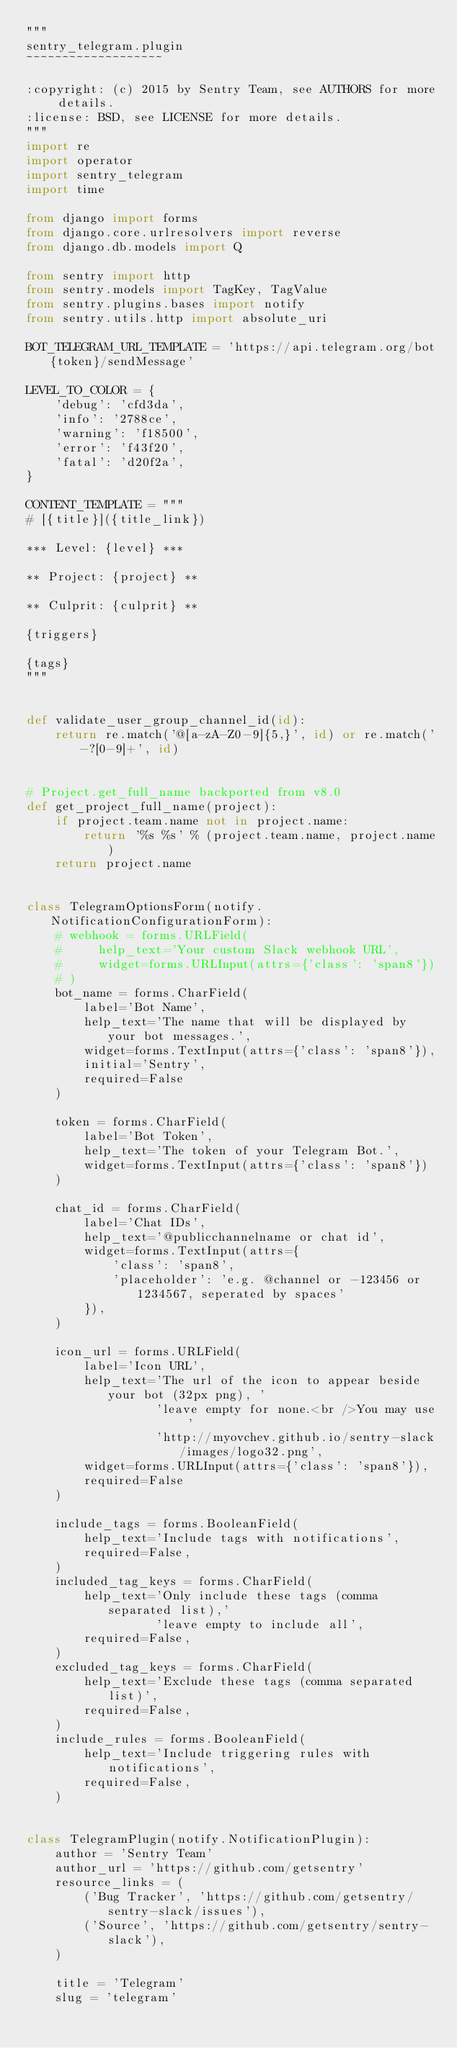<code> <loc_0><loc_0><loc_500><loc_500><_Python_>"""
sentry_telegram.plugin
~~~~~~~~~~~~~~~~~~~

:copyright: (c) 2015 by Sentry Team, see AUTHORS for more details.
:license: BSD, see LICENSE for more details.
"""
import re
import operator
import sentry_telegram
import time

from django import forms
from django.core.urlresolvers import reverse
from django.db.models import Q

from sentry import http
from sentry.models import TagKey, TagValue
from sentry.plugins.bases import notify
from sentry.utils.http import absolute_uri

BOT_TELEGRAM_URL_TEMPLATE = 'https://api.telegram.org/bot{token}/sendMessage'

LEVEL_TO_COLOR = {
    'debug': 'cfd3da',
    'info': '2788ce',
    'warning': 'f18500',
    'error': 'f43f20',
    'fatal': 'd20f2a',
}

CONTENT_TEMPLATE = """
# [{title}]({title_link})

*** Level: {level} ***

** Project: {project} **

** Culprit: {culprit} **

{triggers}

{tags}
"""


def validate_user_group_channel_id(id):
    return re.match('@[a-zA-Z0-9]{5,}', id) or re.match('-?[0-9]+', id)


# Project.get_full_name backported from v8.0
def get_project_full_name(project):
    if project.team.name not in project.name:
        return '%s %s' % (project.team.name, project.name)
    return project.name


class TelegramOptionsForm(notify.NotificationConfigurationForm):
    # webhook = forms.URLField(
    #     help_text='Your custom Slack webhook URL',
    #     widget=forms.URLInput(attrs={'class': 'span8'})
    # )
    bot_name = forms.CharField(
        label='Bot Name',
        help_text='The name that will be displayed by your bot messages.',
        widget=forms.TextInput(attrs={'class': 'span8'}),
        initial='Sentry',
        required=False
    )

    token = forms.CharField(
        label='Bot Token',
        help_text='The token of your Telegram Bot.',
        widget=forms.TextInput(attrs={'class': 'span8'})
    )

    chat_id = forms.CharField(
        label='Chat IDs',
        help_text='@publicchannelname or chat id',
        widget=forms.TextInput(attrs={
            'class': 'span8',
            'placeholder': 'e.g. @channel or -123456 or 1234567, seperated by spaces'
        }),
    )

    icon_url = forms.URLField(
        label='Icon URL',
        help_text='The url of the icon to appear beside your bot (32px png), '
                  'leave empty for none.<br />You may use '
                  'http://myovchev.github.io/sentry-slack/images/logo32.png',
        widget=forms.URLInput(attrs={'class': 'span8'}),
        required=False
    )

    include_tags = forms.BooleanField(
        help_text='Include tags with notifications',
        required=False,
    )
    included_tag_keys = forms.CharField(
        help_text='Only include these tags (comma separated list),'
                  'leave empty to include all',
        required=False,
    )
    excluded_tag_keys = forms.CharField(
        help_text='Exclude these tags (comma separated list)',
        required=False,
    )
    include_rules = forms.BooleanField(
        help_text='Include triggering rules with notifications',
        required=False,
    )


class TelegramPlugin(notify.NotificationPlugin):
    author = 'Sentry Team'
    author_url = 'https://github.com/getsentry'
    resource_links = (
        ('Bug Tracker', 'https://github.com/getsentry/sentry-slack/issues'),
        ('Source', 'https://github.com/getsentry/sentry-slack'),
    )

    title = 'Telegram'
    slug = 'telegram'</code> 